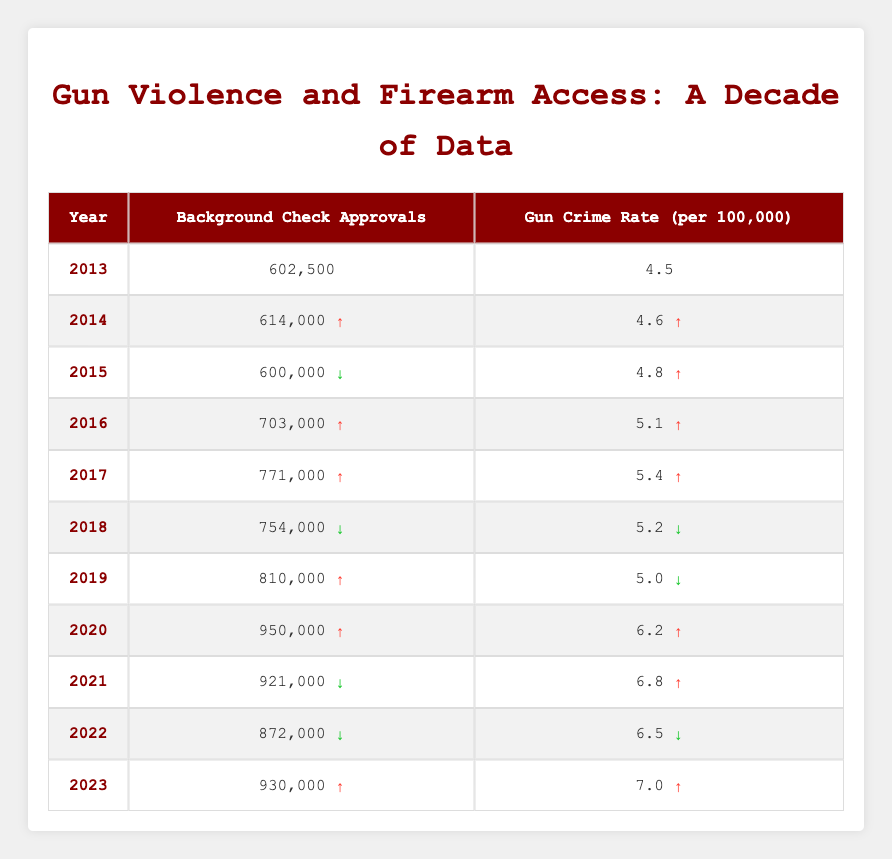What was the year with the highest number of background check approvals? Looking through the table, I see that 2020 has the highest value for background check approvals at 950,000.
Answer: 2020 Did the gun crime rate increase or decrease from 2018 to 2019? From 2018, the gun crime rate was 5.2, and in 2019, it decreased to 5.0.
Answer: Decrease What is the difference in background check approvals between 2013 and 2023? In 2013, the approvals were 602,500, and in 2023 they were 930,000. The difference is calculated as 930,000 - 602,500 = 327,500.
Answer: 327,500 Was there a year when both background check approvals and gun crime rates decreased compared to the previous year? Looking at the table, in 2018, both the background check approvals (754,000) and the gun crime rate (5.2) decreased compared to 2017 (771,000 and 5.4 respectively).
Answer: Yes What was the average gun crime rate over the decade? To find the average gun crime rate, I add the gun crime rates from each year: (4.5 + 4.6 + 4.8 + 5.1 + 5.4 + 5.2 + 5.0 + 6.2 + 6.8 + 6.5 + 7.0) = 57.7. There are 11 years, so the average is 57.7/11 ≈ 5.24.
Answer: Approximately 5.24 Was there a significant increase in gun crime rates from 2019 to 2020? Yes, in 2019, the gun crime rate was 5.0, and it increased significantly to 6.2 in 2020, which shows a rise of 1.2.
Answer: Yes Which year had more background check approvals: 2016 or 2017? In 2016, there were 703,000 approvals, while in 2017, there were 771,000. Therefore, 2017 had more approvals.
Answer: 2017 How many years experienced a gun crime rate higher than 6.0? Looking at the table, the years 2020 (6.2), 2021 (6.8), 2022 (6.5), and 2023 (7.0) all had gun crime rates higher than 6.0. That totals to 4 years.
Answer: 4 